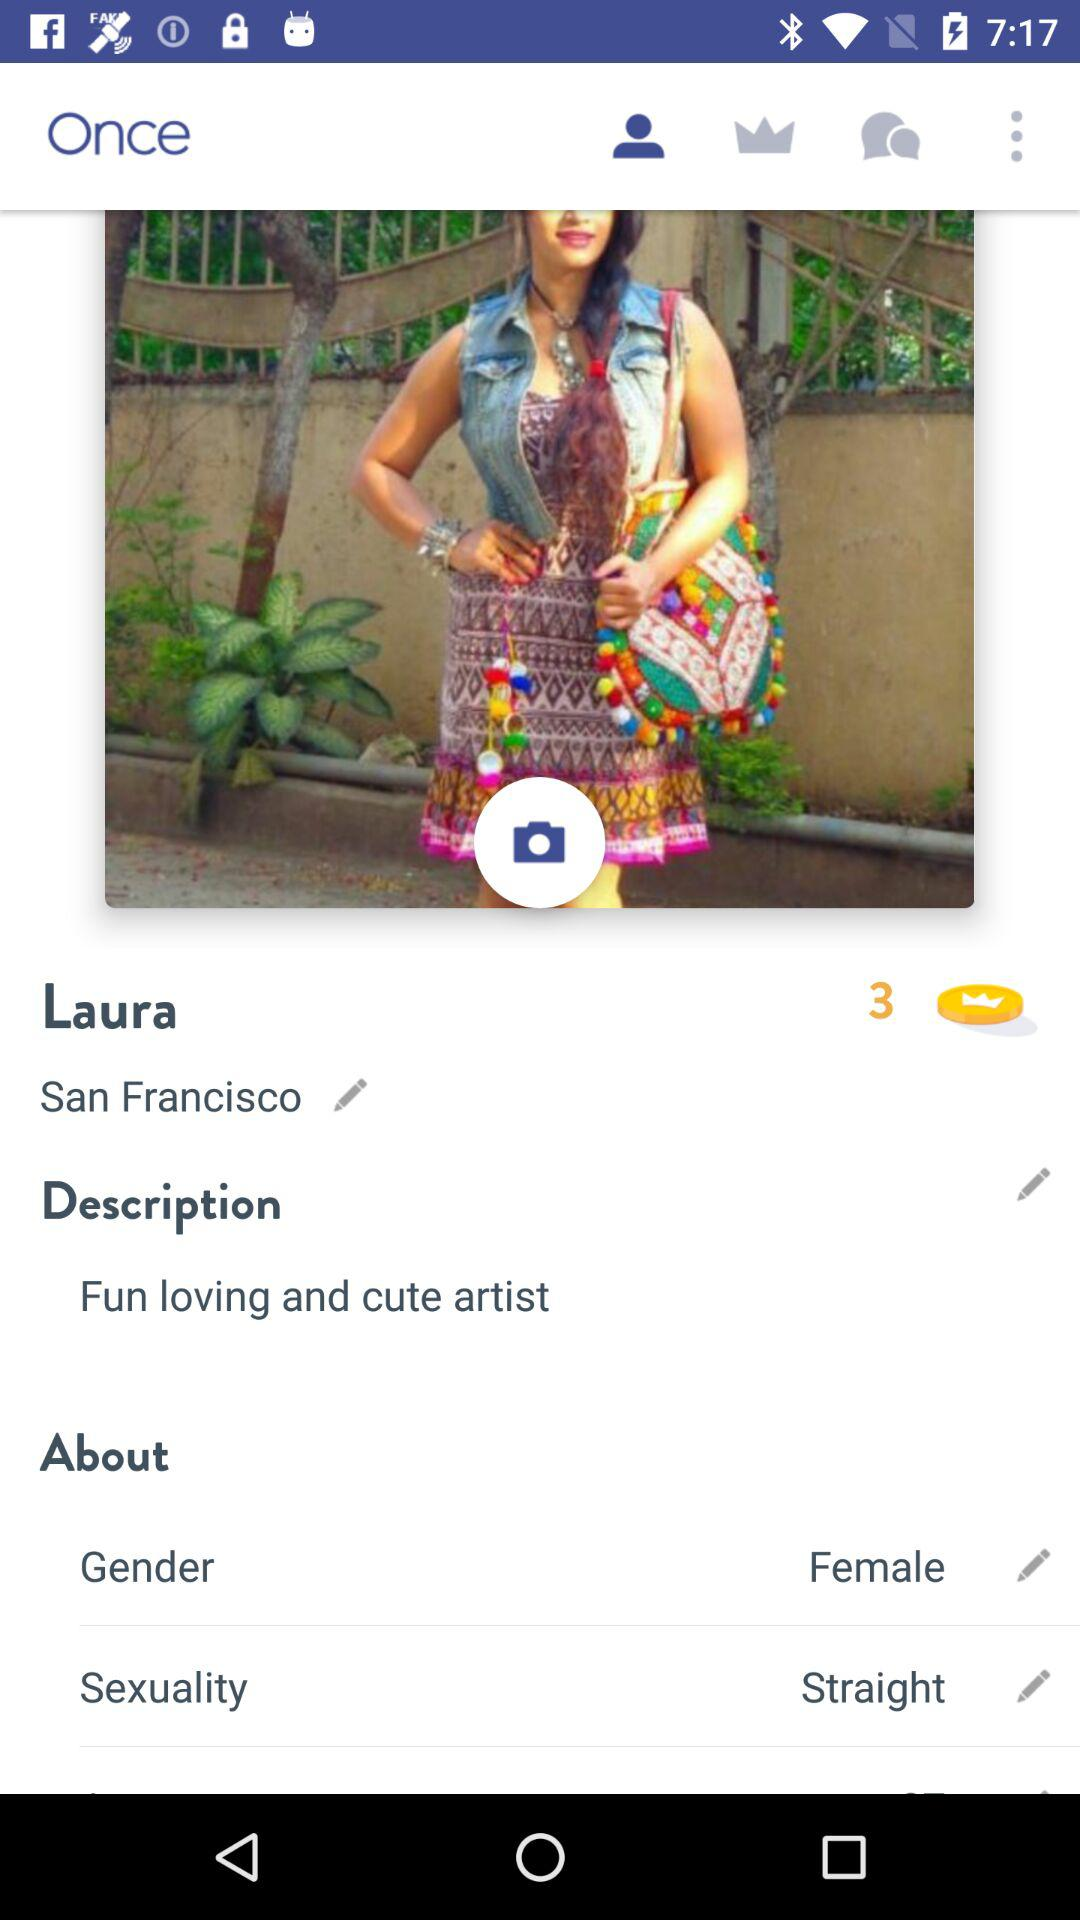What is the sexuality? The sexuality is straight. 